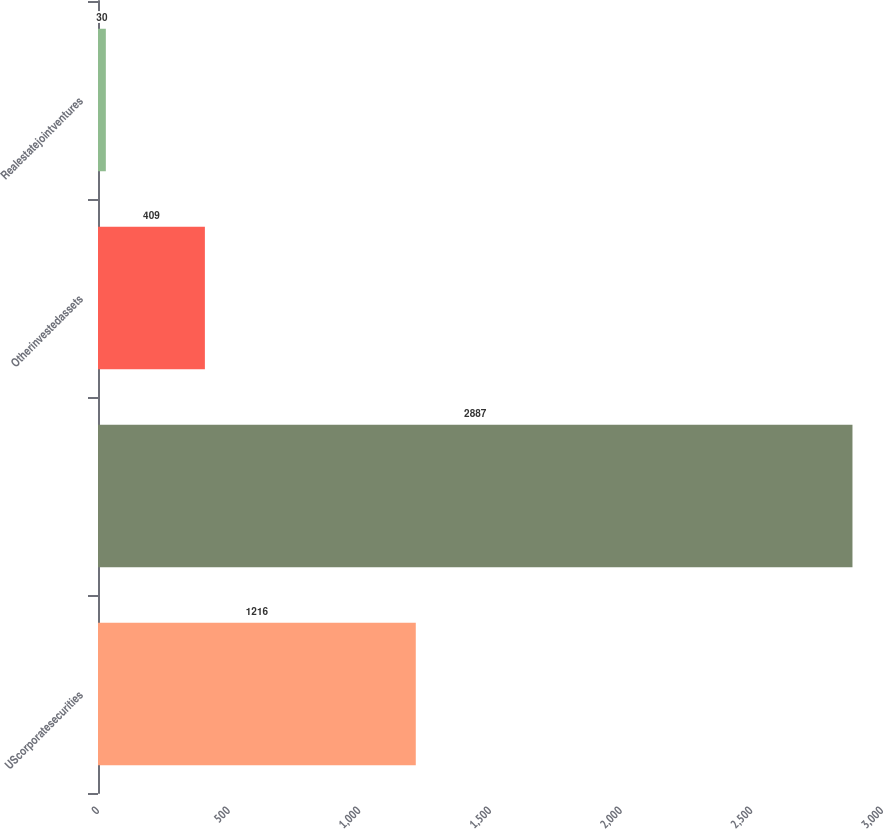<chart> <loc_0><loc_0><loc_500><loc_500><bar_chart><fcel>UScorporatesecurities<fcel>Unnamed: 1<fcel>Otherinvestedassets<fcel>Realestatejointventures<nl><fcel>1216<fcel>2887<fcel>409<fcel>30<nl></chart> 